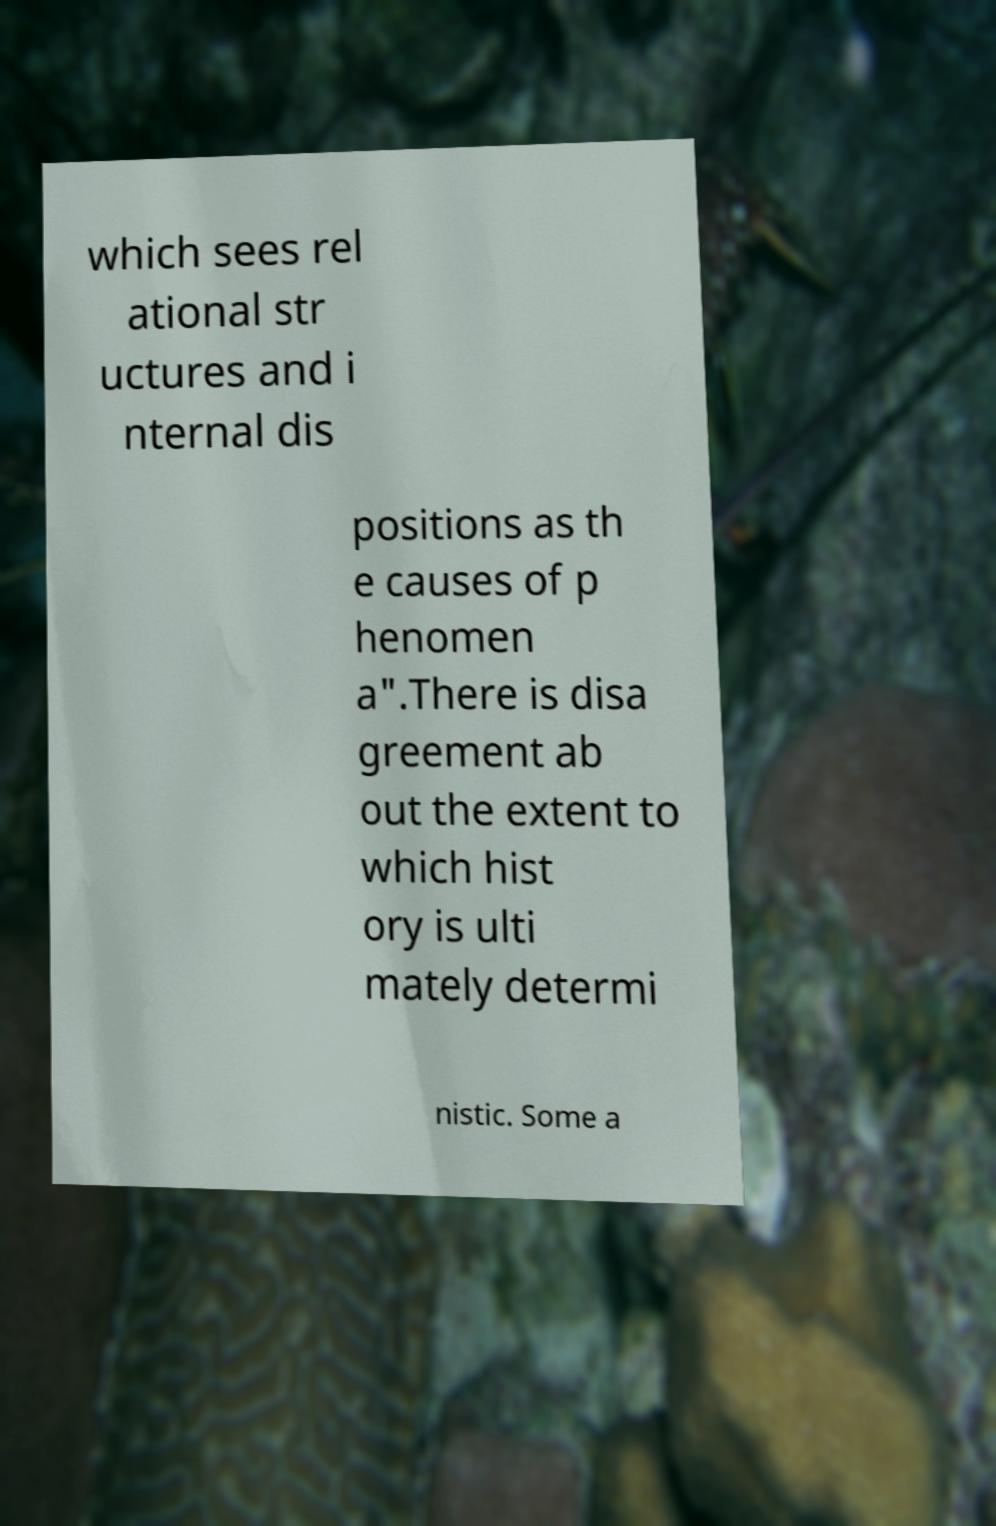Can you read and provide the text displayed in the image?This photo seems to have some interesting text. Can you extract and type it out for me? which sees rel ational str uctures and i nternal dis positions as th e causes of p henomen a".There is disa greement ab out the extent to which hist ory is ulti mately determi nistic. Some a 